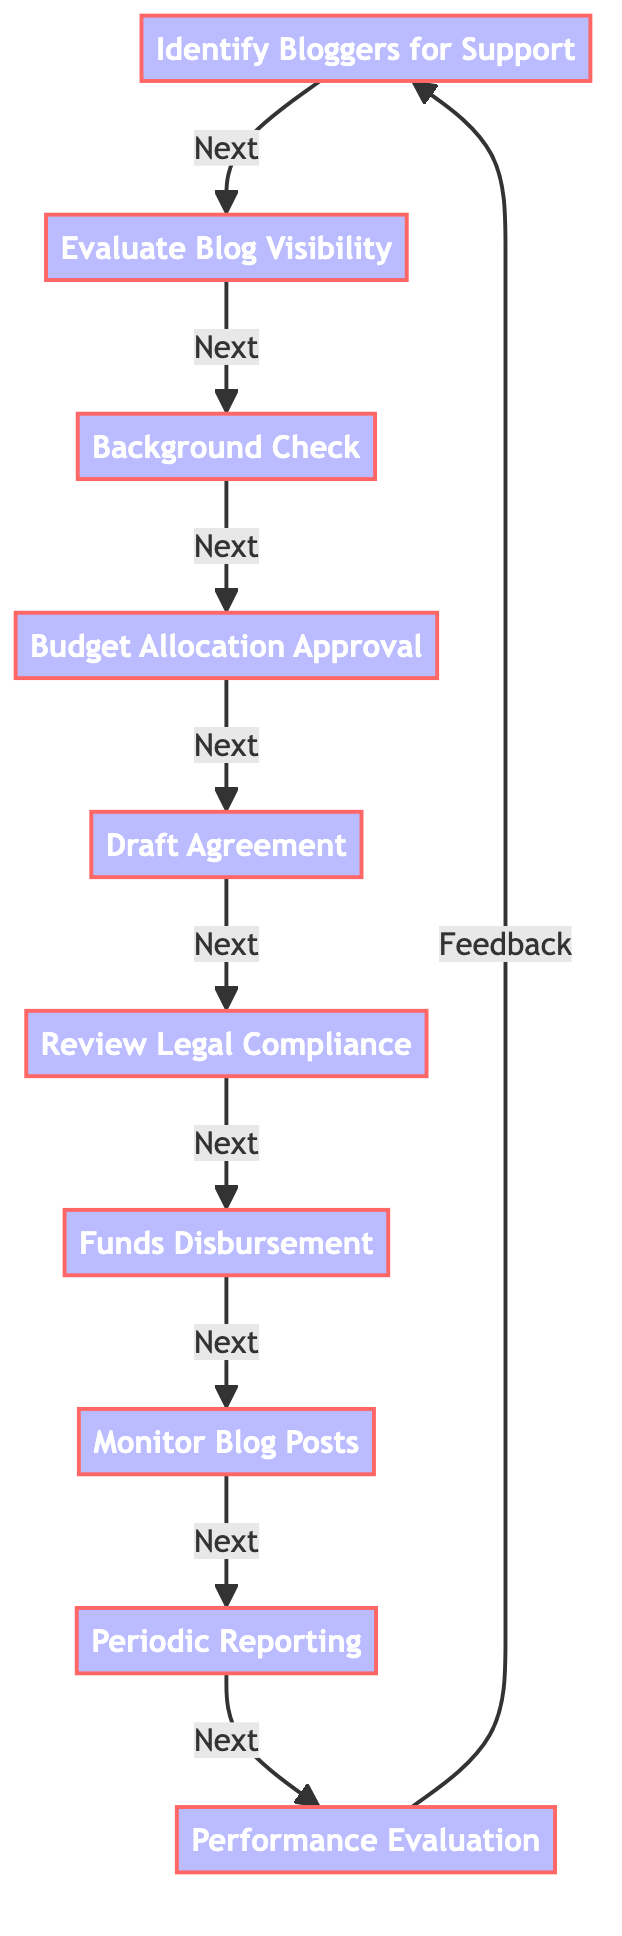What is the first step in the process? The first step in the process is identified by the first node in the flowchart, which states "Identify Bloggers for Support." This indicates the initial action taken to start the allocation process.
Answer: Identify Bloggers for Support How many total steps are there in the process? The flowchart contains a total of ten nodes, representing ten distinct steps in the process of allocating financial support to bloggers. By counting each node, we find that there are ten steps.
Answer: Ten What follows after "Background Check"? The flowchart indicates that the step immediately following "Background Check" is "Budget Allocation Approval," as the arrows guide the flow from one step to the next.
Answer: Budget Allocation Approval Which step involves funding transfer? The step that involves funding transfer is identified as "Funds Disbursement." This step is specifically designed for transferring the agreed-upon funds to the bloggers.
Answer: Funds Disbursement What is the last step in the process? The last step in the flowchart is "Performance Evaluation." This step assesses how effective the support has been based on public sentiment and coverage quality, completing the process cycle.
Answer: Performance Evaluation What step comes before "Monitor Blog Posts"? "Funds Disbursement" is the step that comes directly before "Monitor Blog Posts" in the flowchart. This can be determined by following the directional arrows linking the nodes.
Answer: Funds Disbursement How does the process indicate feedback? The process incorporates feedback by drawing an arrow from the final step "Performance Evaluation" back to the first step "Identify Bloggers for Support," indicating a cyclical nature of the process where evaluations may inform future identifications.
Answer: Feedback Which steps require approval during the process? The steps requiring approval are "Budget Allocation Approval" and "Review Legal Compliance." Both of these steps involve obtaining necessary permissions before proceeding.
Answer: Budget Allocation Approval, Review Legal Compliance What is the main focus of "Periodic Reporting"? "Periodic Reporting" focuses on requiring bloggers to provide updates on how the financial support is being utilized, ensuring accountability and transparency regarding the funds.
Answer: Utilization of support 